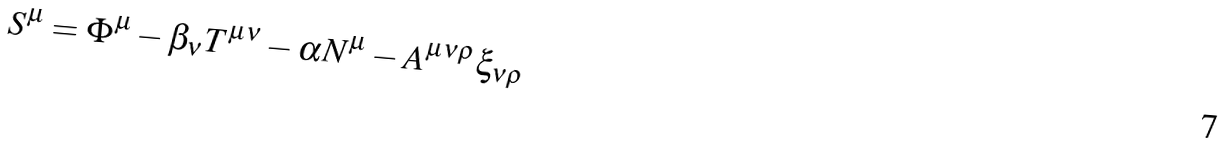<formula> <loc_0><loc_0><loc_500><loc_500>S ^ { \mu } = \Phi ^ { \mu } - \beta _ { \nu } T ^ { \mu \nu } - \alpha N ^ { \mu } - A ^ { \mu \nu \rho } \xi _ { \nu \rho }</formula> 